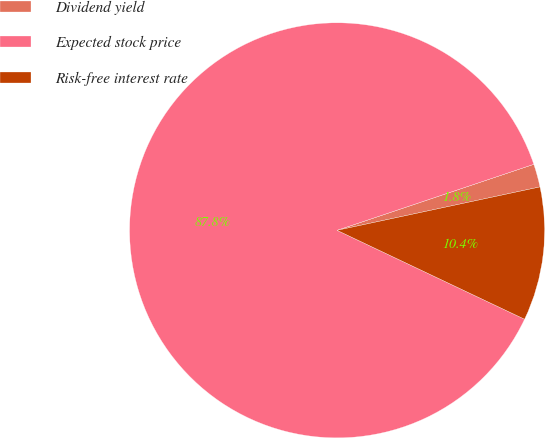Convert chart to OTSL. <chart><loc_0><loc_0><loc_500><loc_500><pie_chart><fcel>Dividend yield<fcel>Expected stock price<fcel>Risk-free interest rate<nl><fcel>1.8%<fcel>87.8%<fcel>10.4%<nl></chart> 